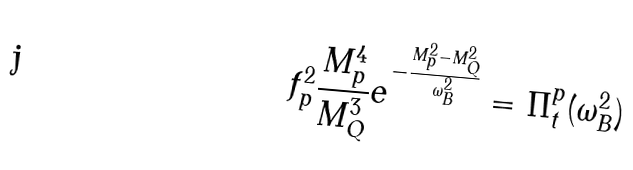<formula> <loc_0><loc_0><loc_500><loc_500>f _ { p } ^ { 2 } \frac { M _ { p } ^ { 4 } } { M _ { Q } ^ { 3 } } e ^ { - \frac { M _ { p } ^ { 2 } - M _ { Q } ^ { 2 } } { \omega _ { B } ^ { 2 } } } = \Pi _ { t } ^ { p } ( \omega _ { B } ^ { 2 } )</formula> 